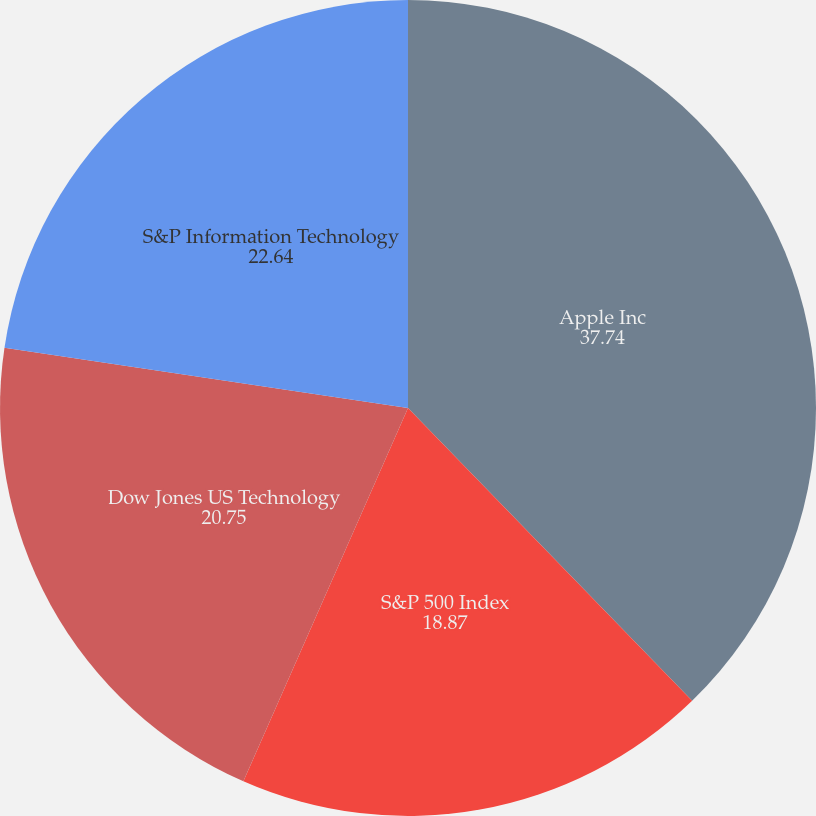Convert chart. <chart><loc_0><loc_0><loc_500><loc_500><pie_chart><fcel>Apple Inc<fcel>S&P 500 Index<fcel>Dow Jones US Technology<fcel>S&P Information Technology<nl><fcel>37.74%<fcel>18.87%<fcel>20.75%<fcel>22.64%<nl></chart> 